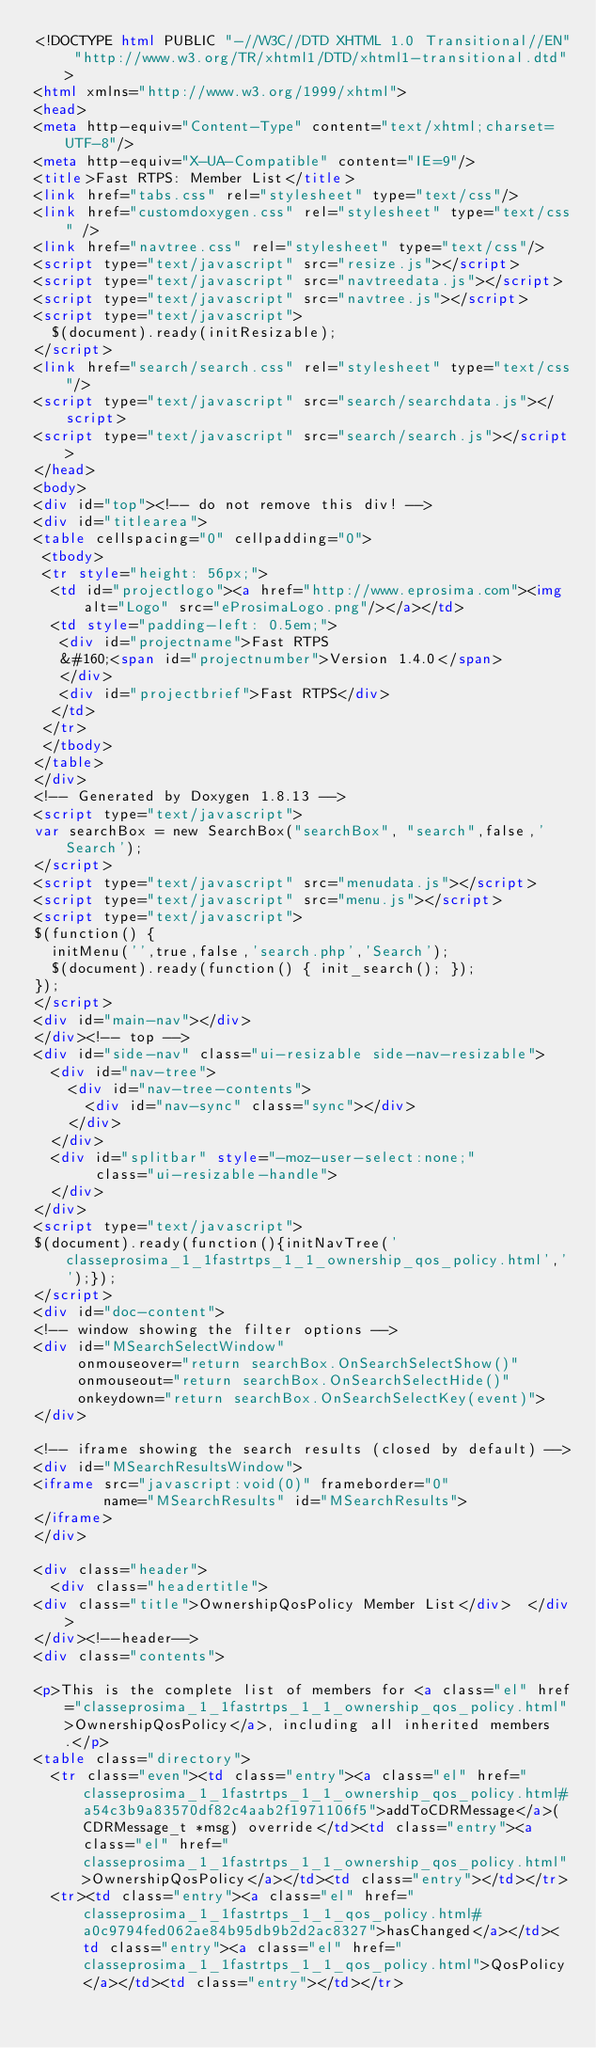<code> <loc_0><loc_0><loc_500><loc_500><_HTML_><!DOCTYPE html PUBLIC "-//W3C//DTD XHTML 1.0 Transitional//EN" "http://www.w3.org/TR/xhtml1/DTD/xhtml1-transitional.dtd">
<html xmlns="http://www.w3.org/1999/xhtml">
<head>
<meta http-equiv="Content-Type" content="text/xhtml;charset=UTF-8"/>
<meta http-equiv="X-UA-Compatible" content="IE=9"/>
<title>Fast RTPS: Member List</title>
<link href="tabs.css" rel="stylesheet" type="text/css"/>
<link href="customdoxygen.css" rel="stylesheet" type="text/css" />
<link href="navtree.css" rel="stylesheet" type="text/css"/>
<script type="text/javascript" src="resize.js"></script>
<script type="text/javascript" src="navtreedata.js"></script>
<script type="text/javascript" src="navtree.js"></script>
<script type="text/javascript">
  $(document).ready(initResizable);
</script>
<link href="search/search.css" rel="stylesheet" type="text/css"/>
<script type="text/javascript" src="search/searchdata.js"></script>
<script type="text/javascript" src="search/search.js"></script>
</head>
<body>
<div id="top"><!-- do not remove this div! -->
<div id="titlearea">
<table cellspacing="0" cellpadding="0">
 <tbody>
 <tr style="height: 56px;">
  <td id="projectlogo"><a href="http://www.eprosima.com"><img alt="Logo" src="eProsimaLogo.png"/></a></td>
  <td style="padding-left: 0.5em;">
   <div id="projectname">Fast RTPS
   &#160;<span id="projectnumber">Version 1.4.0</span>
   </div>
   <div id="projectbrief">Fast RTPS</div>
  </td>
 </tr>
 </tbody>
</table>
</div>
<!-- Generated by Doxygen 1.8.13 -->
<script type="text/javascript">
var searchBox = new SearchBox("searchBox", "search",false,'Search');
</script>
<script type="text/javascript" src="menudata.js"></script>
<script type="text/javascript" src="menu.js"></script>
<script type="text/javascript">
$(function() {
  initMenu('',true,false,'search.php','Search');
  $(document).ready(function() { init_search(); });
});
</script>
<div id="main-nav"></div>
</div><!-- top -->
<div id="side-nav" class="ui-resizable side-nav-resizable">
  <div id="nav-tree">
    <div id="nav-tree-contents">
      <div id="nav-sync" class="sync"></div>
    </div>
  </div>
  <div id="splitbar" style="-moz-user-select:none;" 
       class="ui-resizable-handle">
  </div>
</div>
<script type="text/javascript">
$(document).ready(function(){initNavTree('classeprosima_1_1fastrtps_1_1_ownership_qos_policy.html','');});
</script>
<div id="doc-content">
<!-- window showing the filter options -->
<div id="MSearchSelectWindow"
     onmouseover="return searchBox.OnSearchSelectShow()"
     onmouseout="return searchBox.OnSearchSelectHide()"
     onkeydown="return searchBox.OnSearchSelectKey(event)">
</div>

<!-- iframe showing the search results (closed by default) -->
<div id="MSearchResultsWindow">
<iframe src="javascript:void(0)" frameborder="0" 
        name="MSearchResults" id="MSearchResults">
</iframe>
</div>

<div class="header">
  <div class="headertitle">
<div class="title">OwnershipQosPolicy Member List</div>  </div>
</div><!--header-->
<div class="contents">

<p>This is the complete list of members for <a class="el" href="classeprosima_1_1fastrtps_1_1_ownership_qos_policy.html">OwnershipQosPolicy</a>, including all inherited members.</p>
<table class="directory">
  <tr class="even"><td class="entry"><a class="el" href="classeprosima_1_1fastrtps_1_1_ownership_qos_policy.html#a54c3b9a83570df82c4aab2f1971106f5">addToCDRMessage</a>(CDRMessage_t *msg) override</td><td class="entry"><a class="el" href="classeprosima_1_1fastrtps_1_1_ownership_qos_policy.html">OwnershipQosPolicy</a></td><td class="entry"></td></tr>
  <tr><td class="entry"><a class="el" href="classeprosima_1_1fastrtps_1_1_qos_policy.html#a0c9794fed062ae84b95db9b2d2ac8327">hasChanged</a></td><td class="entry"><a class="el" href="classeprosima_1_1fastrtps_1_1_qos_policy.html">QosPolicy</a></td><td class="entry"></td></tr></code> 